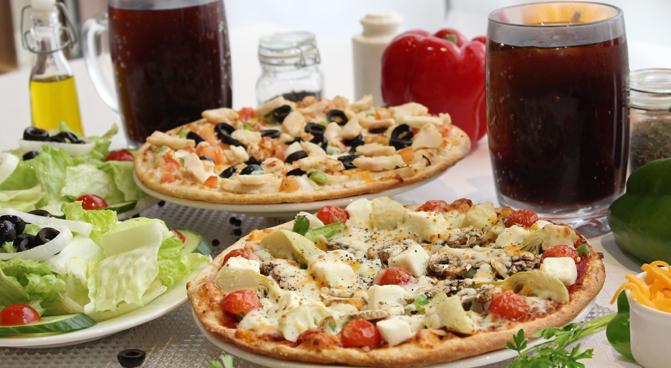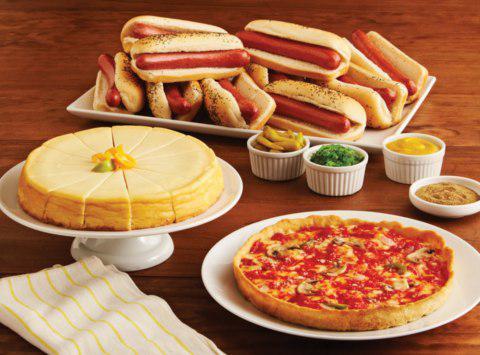The first image is the image on the left, the second image is the image on the right. For the images shown, is this caption "One image includes salads on plates, a green bell pepper and a small white bowl of orange shredded cheese near two pizzas." true? Answer yes or no. Yes. The first image is the image on the left, the second image is the image on the right. Examine the images to the left and right. Is the description "An unopened container of soda is served with a pizza in one of the images." accurate? Answer yes or no. No. 